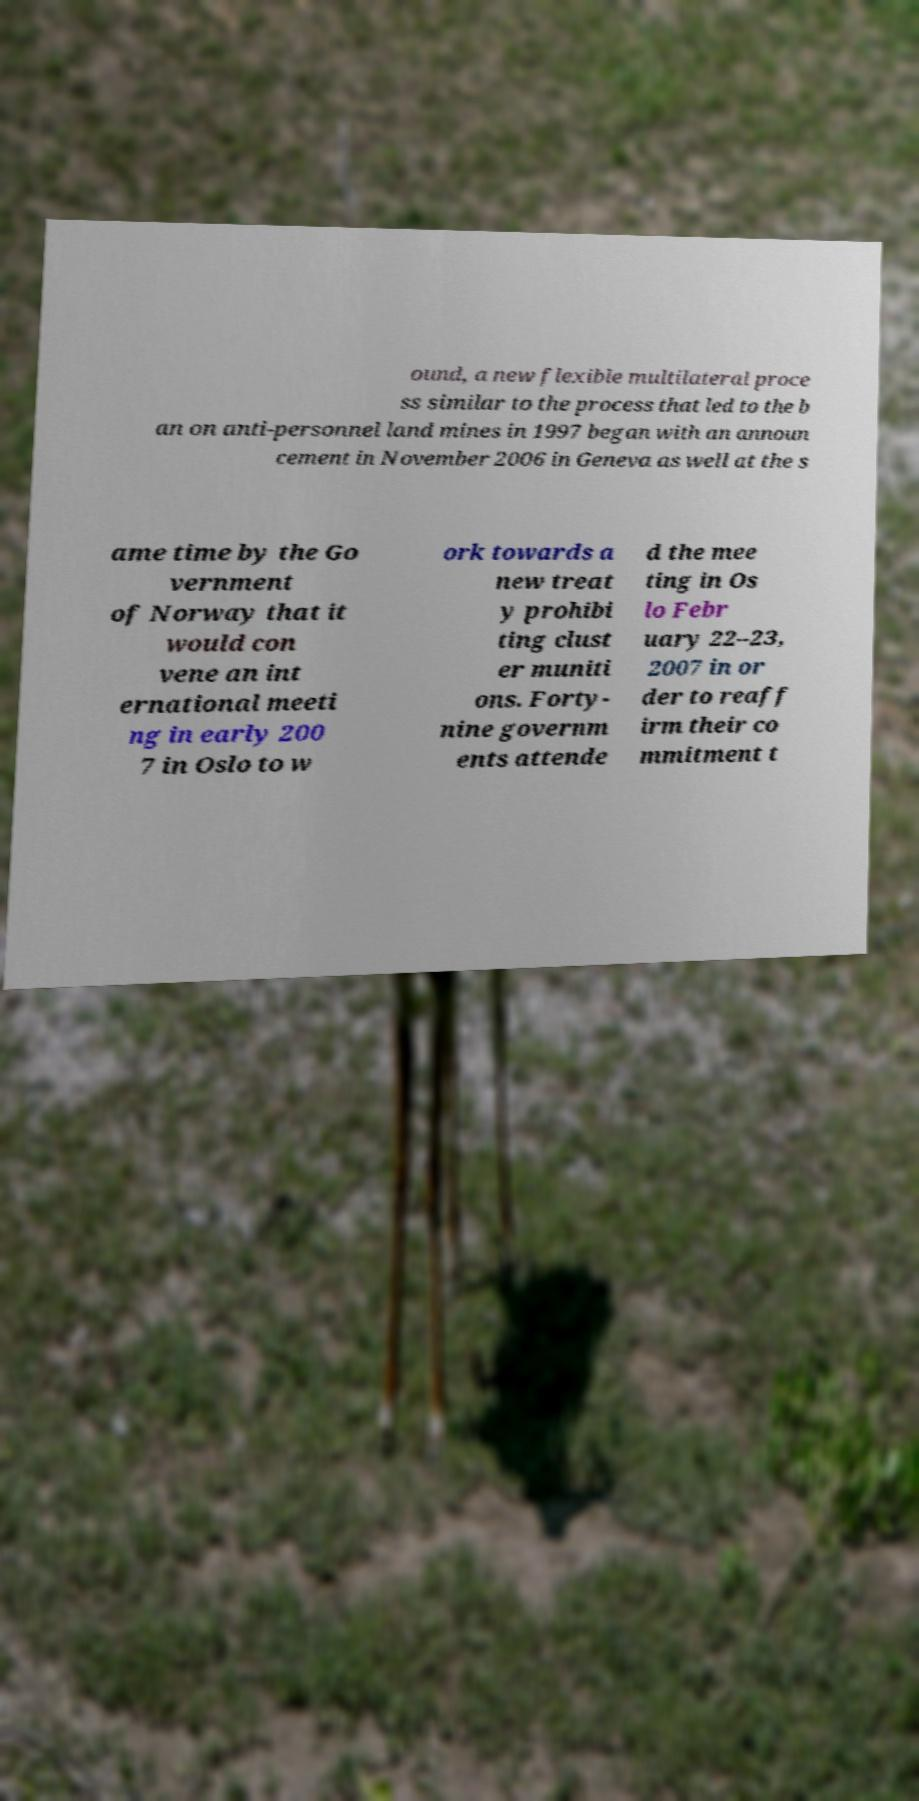There's text embedded in this image that I need extracted. Can you transcribe it verbatim? ound, a new flexible multilateral proce ss similar to the process that led to the b an on anti-personnel land mines in 1997 began with an announ cement in November 2006 in Geneva as well at the s ame time by the Go vernment of Norway that it would con vene an int ernational meeti ng in early 200 7 in Oslo to w ork towards a new treat y prohibi ting clust er muniti ons. Forty- nine governm ents attende d the mee ting in Os lo Febr uary 22–23, 2007 in or der to reaff irm their co mmitment t 